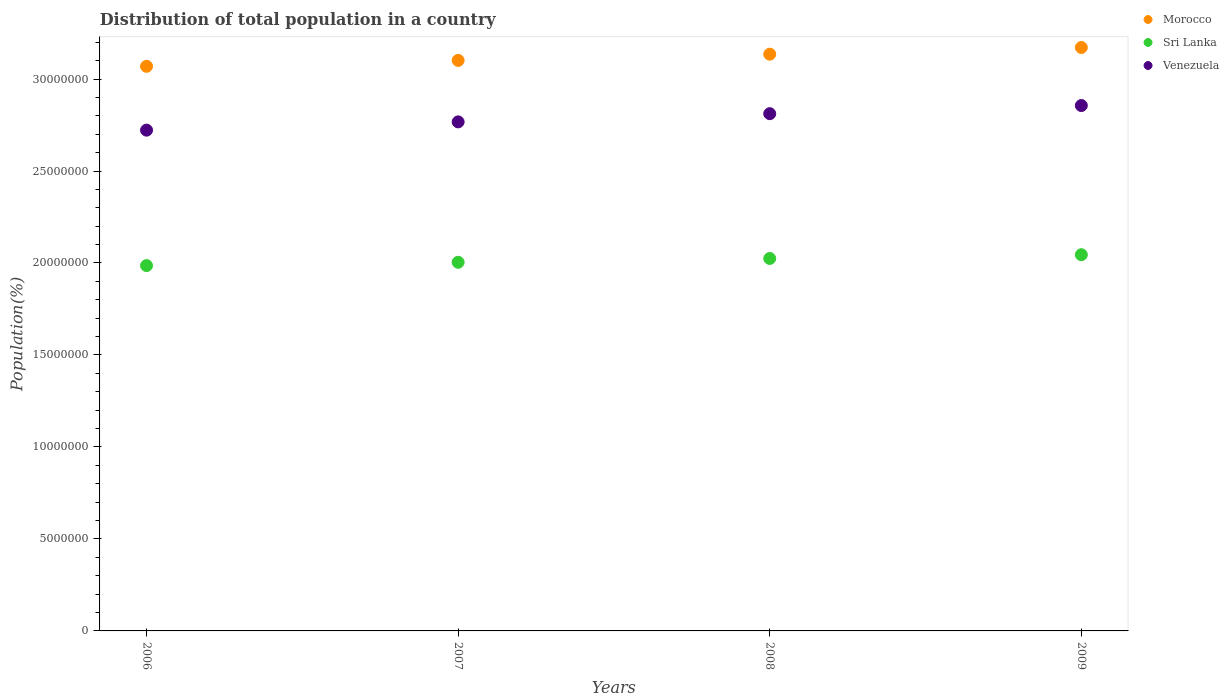What is the population of in Morocco in 2009?
Offer a very short reply. 3.17e+07. Across all years, what is the maximum population of in Sri Lanka?
Offer a terse response. 2.04e+07. Across all years, what is the minimum population of in Morocco?
Offer a terse response. 3.07e+07. What is the total population of in Sri Lanka in the graph?
Your response must be concise. 8.06e+07. What is the difference between the population of in Venezuela in 2007 and that in 2008?
Your answer should be very brief. -4.46e+05. What is the difference between the population of in Sri Lanka in 2006 and the population of in Morocco in 2009?
Provide a succinct answer. -1.19e+07. What is the average population of in Sri Lanka per year?
Your answer should be very brief. 2.01e+07. In the year 2009, what is the difference between the population of in Morocco and population of in Venezuela?
Make the answer very short. 3.16e+06. What is the ratio of the population of in Sri Lanka in 2006 to that in 2008?
Keep it short and to the point. 0.98. What is the difference between the highest and the second highest population of in Venezuela?
Make the answer very short. 4.42e+05. What is the difference between the highest and the lowest population of in Morocco?
Provide a succinct answer. 1.02e+06. Is the population of in Venezuela strictly less than the population of in Morocco over the years?
Make the answer very short. Yes. How many dotlines are there?
Your response must be concise. 3. What is the difference between two consecutive major ticks on the Y-axis?
Make the answer very short. 5.00e+06. Does the graph contain any zero values?
Provide a short and direct response. No. Does the graph contain grids?
Make the answer very short. No. Where does the legend appear in the graph?
Ensure brevity in your answer.  Top right. How many legend labels are there?
Your response must be concise. 3. How are the legend labels stacked?
Your answer should be compact. Vertical. What is the title of the graph?
Ensure brevity in your answer.  Distribution of total population in a country. Does "Isle of Man" appear as one of the legend labels in the graph?
Give a very brief answer. No. What is the label or title of the Y-axis?
Provide a short and direct response. Population(%). What is the Population(%) in Morocco in 2006?
Provide a succinct answer. 3.07e+07. What is the Population(%) of Sri Lanka in 2006?
Your answer should be compact. 1.99e+07. What is the Population(%) in Venezuela in 2006?
Offer a very short reply. 2.72e+07. What is the Population(%) of Morocco in 2007?
Ensure brevity in your answer.  3.10e+07. What is the Population(%) of Sri Lanka in 2007?
Keep it short and to the point. 2.00e+07. What is the Population(%) in Venezuela in 2007?
Make the answer very short. 2.77e+07. What is the Population(%) in Morocco in 2008?
Ensure brevity in your answer.  3.14e+07. What is the Population(%) of Sri Lanka in 2008?
Keep it short and to the point. 2.02e+07. What is the Population(%) of Venezuela in 2008?
Keep it short and to the point. 2.81e+07. What is the Population(%) of Morocco in 2009?
Make the answer very short. 3.17e+07. What is the Population(%) in Sri Lanka in 2009?
Provide a succinct answer. 2.04e+07. What is the Population(%) of Venezuela in 2009?
Make the answer very short. 2.86e+07. Across all years, what is the maximum Population(%) in Morocco?
Your answer should be compact. 3.17e+07. Across all years, what is the maximum Population(%) of Sri Lanka?
Ensure brevity in your answer.  2.04e+07. Across all years, what is the maximum Population(%) of Venezuela?
Provide a succinct answer. 2.86e+07. Across all years, what is the minimum Population(%) of Morocco?
Ensure brevity in your answer.  3.07e+07. Across all years, what is the minimum Population(%) in Sri Lanka?
Provide a succinct answer. 1.99e+07. Across all years, what is the minimum Population(%) in Venezuela?
Your response must be concise. 2.72e+07. What is the total Population(%) in Morocco in the graph?
Your answer should be compact. 1.25e+08. What is the total Population(%) in Sri Lanka in the graph?
Offer a terse response. 8.06e+07. What is the total Population(%) in Venezuela in the graph?
Make the answer very short. 1.12e+08. What is the difference between the Population(%) in Morocco in 2006 and that in 2007?
Your answer should be very brief. -3.20e+05. What is the difference between the Population(%) in Sri Lanka in 2006 and that in 2007?
Your answer should be compact. -1.81e+05. What is the difference between the Population(%) in Venezuela in 2006 and that in 2007?
Offer a terse response. -4.49e+05. What is the difference between the Population(%) of Morocco in 2006 and that in 2008?
Give a very brief answer. -6.59e+05. What is the difference between the Population(%) in Sri Lanka in 2006 and that in 2008?
Your answer should be very brief. -3.88e+05. What is the difference between the Population(%) of Venezuela in 2006 and that in 2008?
Provide a short and direct response. -8.95e+05. What is the difference between the Population(%) of Morocco in 2006 and that in 2009?
Your answer should be very brief. -1.02e+06. What is the difference between the Population(%) in Sri Lanka in 2006 and that in 2009?
Provide a short and direct response. -5.92e+05. What is the difference between the Population(%) in Venezuela in 2006 and that in 2009?
Offer a terse response. -1.34e+06. What is the difference between the Population(%) of Morocco in 2007 and that in 2008?
Make the answer very short. -3.39e+05. What is the difference between the Population(%) of Sri Lanka in 2007 and that in 2008?
Offer a terse response. -2.07e+05. What is the difference between the Population(%) of Venezuela in 2007 and that in 2008?
Your response must be concise. -4.46e+05. What is the difference between the Population(%) of Morocco in 2007 and that in 2009?
Your answer should be compact. -7.04e+05. What is the difference between the Population(%) of Sri Lanka in 2007 and that in 2009?
Keep it short and to the point. -4.11e+05. What is the difference between the Population(%) of Venezuela in 2007 and that in 2009?
Give a very brief answer. -8.88e+05. What is the difference between the Population(%) in Morocco in 2008 and that in 2009?
Your answer should be compact. -3.64e+05. What is the difference between the Population(%) of Sri Lanka in 2008 and that in 2009?
Make the answer very short. -2.04e+05. What is the difference between the Population(%) of Venezuela in 2008 and that in 2009?
Give a very brief answer. -4.42e+05. What is the difference between the Population(%) in Morocco in 2006 and the Population(%) in Sri Lanka in 2007?
Your answer should be very brief. 1.07e+07. What is the difference between the Population(%) in Morocco in 2006 and the Population(%) in Venezuela in 2007?
Your answer should be compact. 3.02e+06. What is the difference between the Population(%) in Sri Lanka in 2006 and the Population(%) in Venezuela in 2007?
Provide a short and direct response. -7.81e+06. What is the difference between the Population(%) in Morocco in 2006 and the Population(%) in Sri Lanka in 2008?
Ensure brevity in your answer.  1.04e+07. What is the difference between the Population(%) of Morocco in 2006 and the Population(%) of Venezuela in 2008?
Ensure brevity in your answer.  2.57e+06. What is the difference between the Population(%) in Sri Lanka in 2006 and the Population(%) in Venezuela in 2008?
Your answer should be very brief. -8.26e+06. What is the difference between the Population(%) of Morocco in 2006 and the Population(%) of Sri Lanka in 2009?
Your answer should be very brief. 1.02e+07. What is the difference between the Population(%) of Morocco in 2006 and the Population(%) of Venezuela in 2009?
Offer a terse response. 2.13e+06. What is the difference between the Population(%) of Sri Lanka in 2006 and the Population(%) of Venezuela in 2009?
Your response must be concise. -8.70e+06. What is the difference between the Population(%) of Morocco in 2007 and the Population(%) of Sri Lanka in 2008?
Ensure brevity in your answer.  1.08e+07. What is the difference between the Population(%) in Morocco in 2007 and the Population(%) in Venezuela in 2008?
Your answer should be compact. 2.89e+06. What is the difference between the Population(%) of Sri Lanka in 2007 and the Population(%) of Venezuela in 2008?
Offer a very short reply. -8.08e+06. What is the difference between the Population(%) of Morocco in 2007 and the Population(%) of Sri Lanka in 2009?
Keep it short and to the point. 1.06e+07. What is the difference between the Population(%) in Morocco in 2007 and the Population(%) in Venezuela in 2009?
Offer a very short reply. 2.45e+06. What is the difference between the Population(%) of Sri Lanka in 2007 and the Population(%) of Venezuela in 2009?
Make the answer very short. -8.52e+06. What is the difference between the Population(%) of Morocco in 2008 and the Population(%) of Sri Lanka in 2009?
Your answer should be compact. 1.09e+07. What is the difference between the Population(%) in Morocco in 2008 and the Population(%) in Venezuela in 2009?
Provide a succinct answer. 2.79e+06. What is the difference between the Population(%) of Sri Lanka in 2008 and the Population(%) of Venezuela in 2009?
Offer a terse response. -8.31e+06. What is the average Population(%) of Morocco per year?
Your response must be concise. 3.12e+07. What is the average Population(%) of Sri Lanka per year?
Your response must be concise. 2.01e+07. What is the average Population(%) in Venezuela per year?
Ensure brevity in your answer.  2.79e+07. In the year 2006, what is the difference between the Population(%) of Morocco and Population(%) of Sri Lanka?
Your answer should be compact. 1.08e+07. In the year 2006, what is the difference between the Population(%) of Morocco and Population(%) of Venezuela?
Offer a terse response. 3.47e+06. In the year 2006, what is the difference between the Population(%) in Sri Lanka and Population(%) in Venezuela?
Make the answer very short. -7.36e+06. In the year 2007, what is the difference between the Population(%) of Morocco and Population(%) of Sri Lanka?
Offer a terse response. 1.10e+07. In the year 2007, what is the difference between the Population(%) in Morocco and Population(%) in Venezuela?
Offer a terse response. 3.34e+06. In the year 2007, what is the difference between the Population(%) of Sri Lanka and Population(%) of Venezuela?
Keep it short and to the point. -7.63e+06. In the year 2008, what is the difference between the Population(%) in Morocco and Population(%) in Sri Lanka?
Ensure brevity in your answer.  1.11e+07. In the year 2008, what is the difference between the Population(%) of Morocco and Population(%) of Venezuela?
Offer a very short reply. 3.23e+06. In the year 2008, what is the difference between the Population(%) in Sri Lanka and Population(%) in Venezuela?
Provide a succinct answer. -7.87e+06. In the year 2009, what is the difference between the Population(%) of Morocco and Population(%) of Sri Lanka?
Your response must be concise. 1.13e+07. In the year 2009, what is the difference between the Population(%) in Morocco and Population(%) in Venezuela?
Your answer should be compact. 3.16e+06. In the year 2009, what is the difference between the Population(%) of Sri Lanka and Population(%) of Venezuela?
Your answer should be very brief. -8.11e+06. What is the ratio of the Population(%) of Morocco in 2006 to that in 2007?
Provide a succinct answer. 0.99. What is the ratio of the Population(%) in Sri Lanka in 2006 to that in 2007?
Offer a very short reply. 0.99. What is the ratio of the Population(%) in Venezuela in 2006 to that in 2007?
Your answer should be compact. 0.98. What is the ratio of the Population(%) of Morocco in 2006 to that in 2008?
Your answer should be compact. 0.98. What is the ratio of the Population(%) in Sri Lanka in 2006 to that in 2008?
Offer a very short reply. 0.98. What is the ratio of the Population(%) in Venezuela in 2006 to that in 2008?
Keep it short and to the point. 0.97. What is the ratio of the Population(%) of Sri Lanka in 2006 to that in 2009?
Provide a short and direct response. 0.97. What is the ratio of the Population(%) of Venezuela in 2006 to that in 2009?
Make the answer very short. 0.95. What is the ratio of the Population(%) of Sri Lanka in 2007 to that in 2008?
Provide a short and direct response. 0.99. What is the ratio of the Population(%) of Venezuela in 2007 to that in 2008?
Your answer should be very brief. 0.98. What is the ratio of the Population(%) of Morocco in 2007 to that in 2009?
Offer a terse response. 0.98. What is the ratio of the Population(%) of Sri Lanka in 2007 to that in 2009?
Ensure brevity in your answer.  0.98. What is the ratio of the Population(%) of Venezuela in 2007 to that in 2009?
Provide a short and direct response. 0.97. What is the ratio of the Population(%) in Morocco in 2008 to that in 2009?
Your answer should be very brief. 0.99. What is the ratio of the Population(%) in Sri Lanka in 2008 to that in 2009?
Keep it short and to the point. 0.99. What is the ratio of the Population(%) of Venezuela in 2008 to that in 2009?
Give a very brief answer. 0.98. What is the difference between the highest and the second highest Population(%) of Morocco?
Your answer should be very brief. 3.64e+05. What is the difference between the highest and the second highest Population(%) in Sri Lanka?
Your response must be concise. 2.04e+05. What is the difference between the highest and the second highest Population(%) of Venezuela?
Provide a short and direct response. 4.42e+05. What is the difference between the highest and the lowest Population(%) in Morocco?
Give a very brief answer. 1.02e+06. What is the difference between the highest and the lowest Population(%) in Sri Lanka?
Provide a succinct answer. 5.92e+05. What is the difference between the highest and the lowest Population(%) of Venezuela?
Provide a succinct answer. 1.34e+06. 